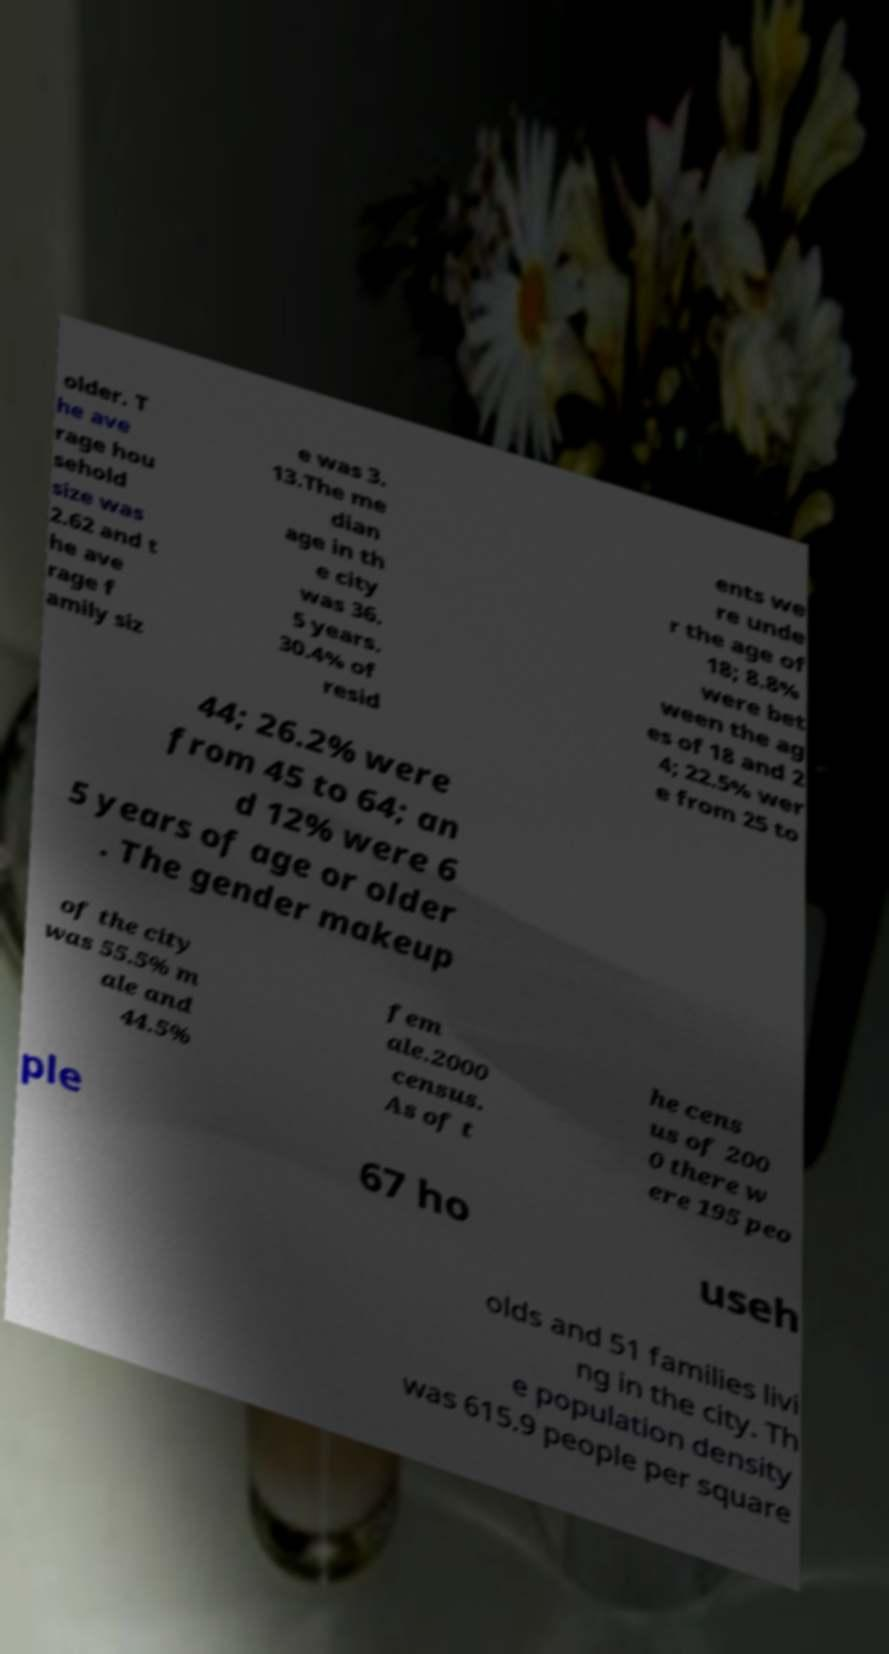Please identify and transcribe the text found in this image. older. T he ave rage hou sehold size was 2.62 and t he ave rage f amily siz e was 3. 13.The me dian age in th e city was 36. 5 years. 30.4% of resid ents we re unde r the age of 18; 8.8% were bet ween the ag es of 18 and 2 4; 22.5% wer e from 25 to 44; 26.2% were from 45 to 64; an d 12% were 6 5 years of age or older . The gender makeup of the city was 55.5% m ale and 44.5% fem ale.2000 census. As of t he cens us of 200 0 there w ere 195 peo ple 67 ho useh olds and 51 families livi ng in the city. Th e population density was 615.9 people per square 